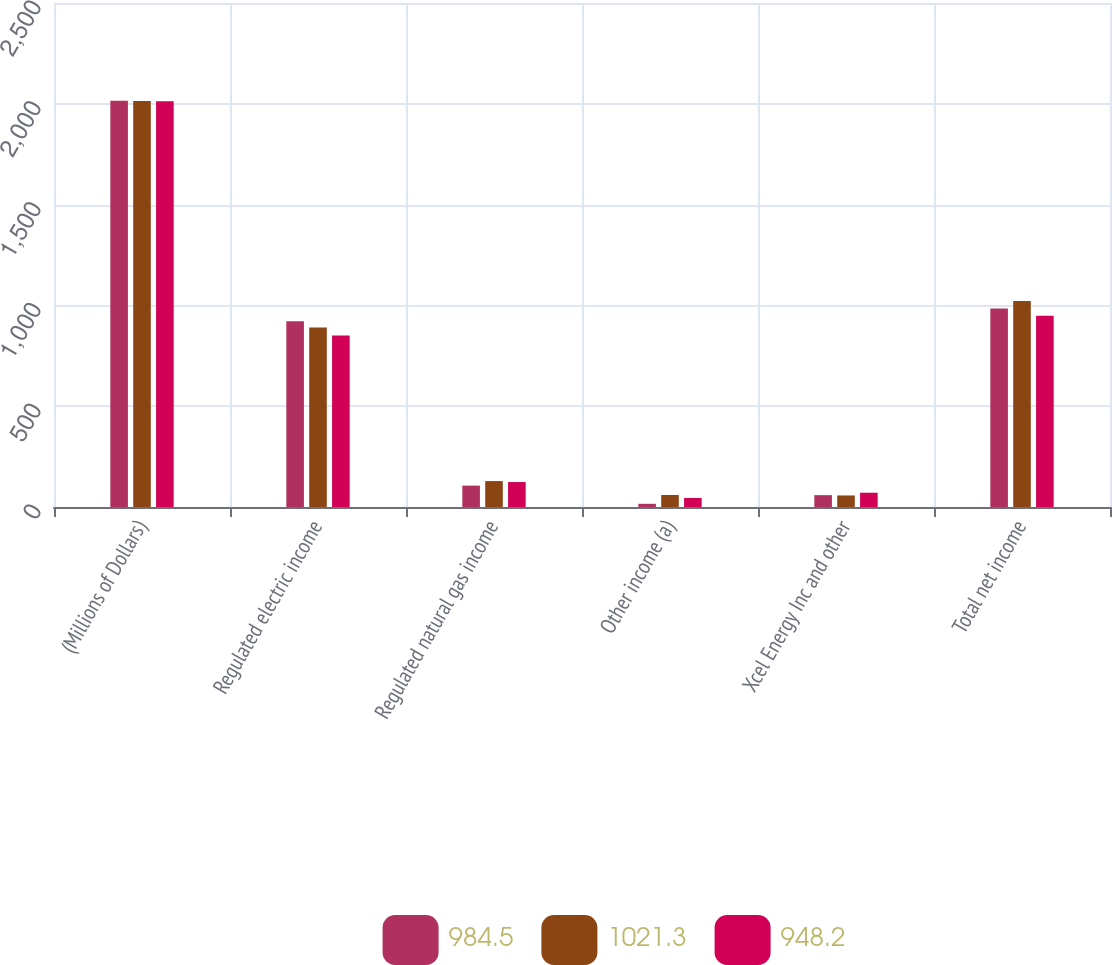<chart> <loc_0><loc_0><loc_500><loc_500><stacked_bar_chart><ecel><fcel>(Millions of Dollars)<fcel>Regulated electric income<fcel>Regulated natural gas income<fcel>Other income (a)<fcel>Xcel Energy Inc and other<fcel>Total net income<nl><fcel>984.5<fcel>2015<fcel>921.4<fcel>106<fcel>15.8<fcel>58.7<fcel>984.5<nl><fcel>1021.3<fcel>2014<fcel>890.5<fcel>128.6<fcel>59.5<fcel>57.3<fcel>1021.3<nl><fcel>948.2<fcel>2013<fcel>850.7<fcel>123.7<fcel>44.6<fcel>70.8<fcel>948.2<nl></chart> 